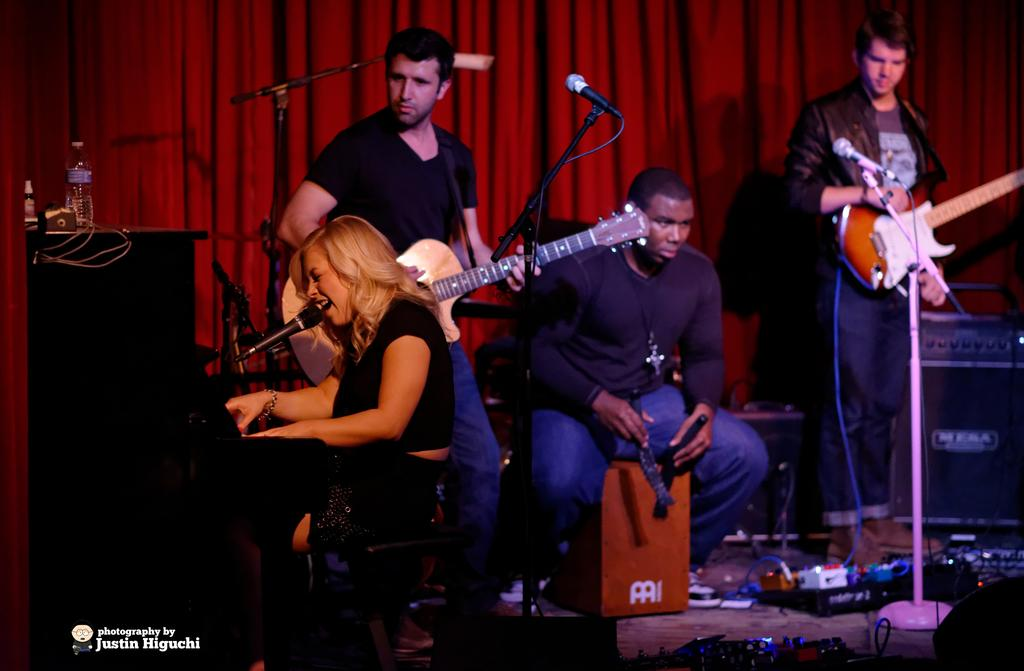How many people are in the image? There are four people in the image. What are the people doing in the image? The people are holding musical instruments. What objects can be seen in the image related to sound? There are speakers in the image. What piece of furniture is present in the image? There is a desk in the image. What is placed on the desk? There are items placed on the desk. What color is the cotton in the image? The cotton in the image is red. Where is the bomb located in the image? There is no bomb present in the image. What type of toothpaste can be seen on the desk in the image? There is no toothpaste present in the image. 